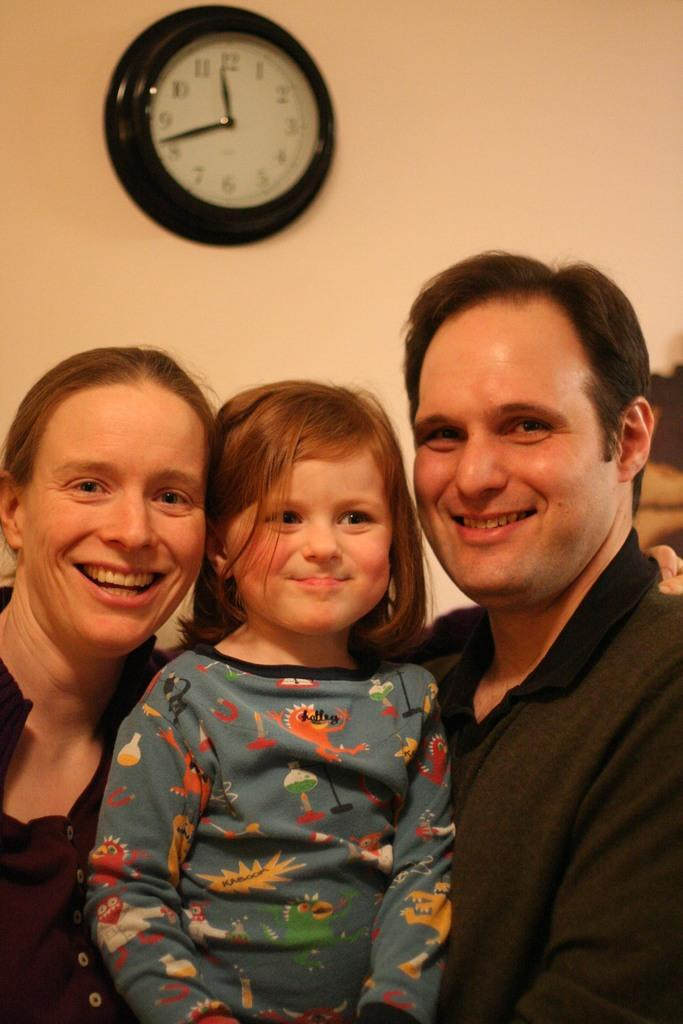<image>
Summarize the visual content of the image. A clock showing the time as 11:42 hangs behind a family. 